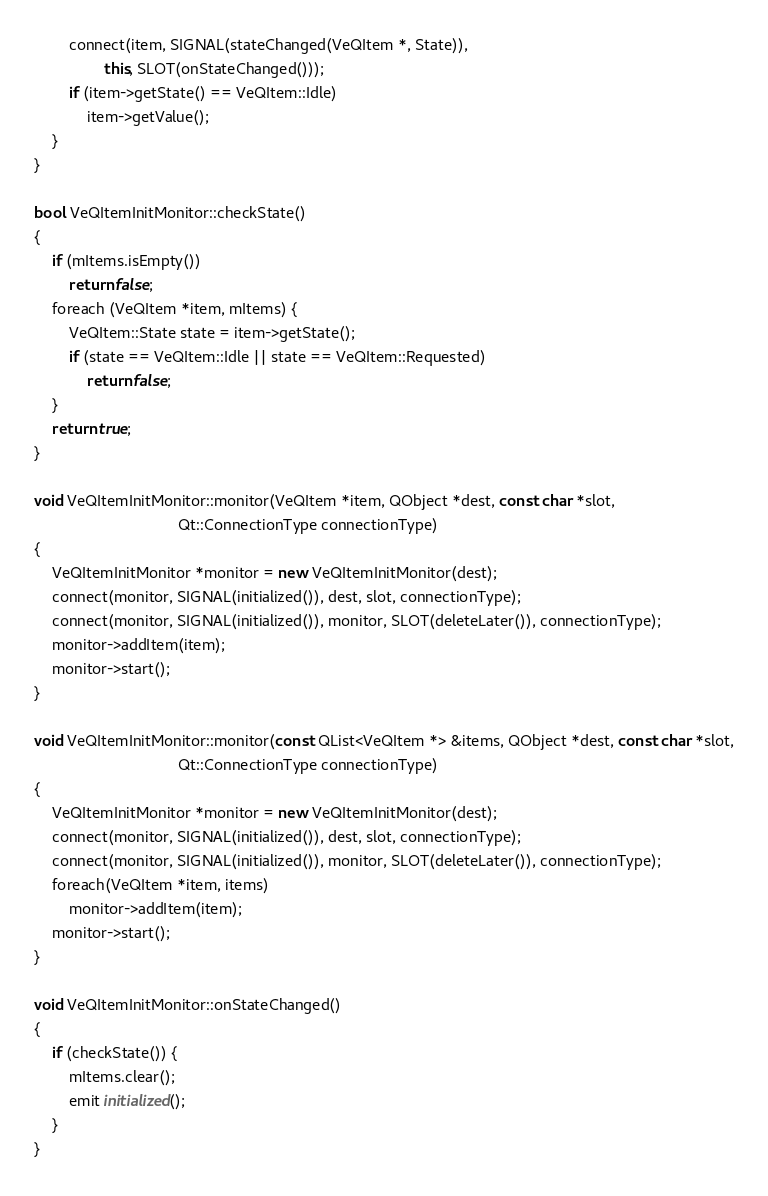<code> <loc_0><loc_0><loc_500><loc_500><_C++_>		connect(item, SIGNAL(stateChanged(VeQItem *, State)),
				this, SLOT(onStateChanged()));
		if (item->getState() == VeQItem::Idle)
			item->getValue();
	}
}

bool VeQItemInitMonitor::checkState()
{
	if (mItems.isEmpty())
		return false;
	foreach (VeQItem *item, mItems) {
		VeQItem::State state = item->getState();
		if (state == VeQItem::Idle || state == VeQItem::Requested)
			return false;
	}
	return true;
}

void VeQItemInitMonitor::monitor(VeQItem *item, QObject *dest, const char *slot,
								 Qt::ConnectionType connectionType)
{
	VeQItemInitMonitor *monitor = new VeQItemInitMonitor(dest);
	connect(monitor, SIGNAL(initialized()), dest, slot, connectionType);
	connect(monitor, SIGNAL(initialized()), monitor, SLOT(deleteLater()), connectionType);
	monitor->addItem(item);
	monitor->start();
}

void VeQItemInitMonitor::monitor(const QList<VeQItem *> &items, QObject *dest, const char *slot,
								 Qt::ConnectionType connectionType)
{
	VeQItemInitMonitor *monitor = new VeQItemInitMonitor(dest);
	connect(monitor, SIGNAL(initialized()), dest, slot, connectionType);
	connect(monitor, SIGNAL(initialized()), monitor, SLOT(deleteLater()), connectionType);
	foreach(VeQItem *item, items)
		monitor->addItem(item);
	monitor->start();
}

void VeQItemInitMonitor::onStateChanged()
{
	if (checkState()) {
		mItems.clear();
		emit initialized();
	}
}
</code> 